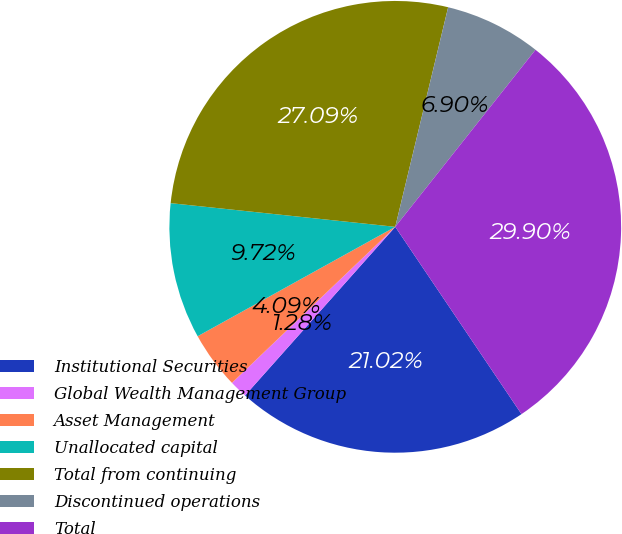Convert chart. <chart><loc_0><loc_0><loc_500><loc_500><pie_chart><fcel>Institutional Securities<fcel>Global Wealth Management Group<fcel>Asset Management<fcel>Unallocated capital<fcel>Total from continuing<fcel>Discontinued operations<fcel>Total<nl><fcel>21.02%<fcel>1.28%<fcel>4.09%<fcel>9.72%<fcel>27.09%<fcel>6.9%<fcel>29.9%<nl></chart> 